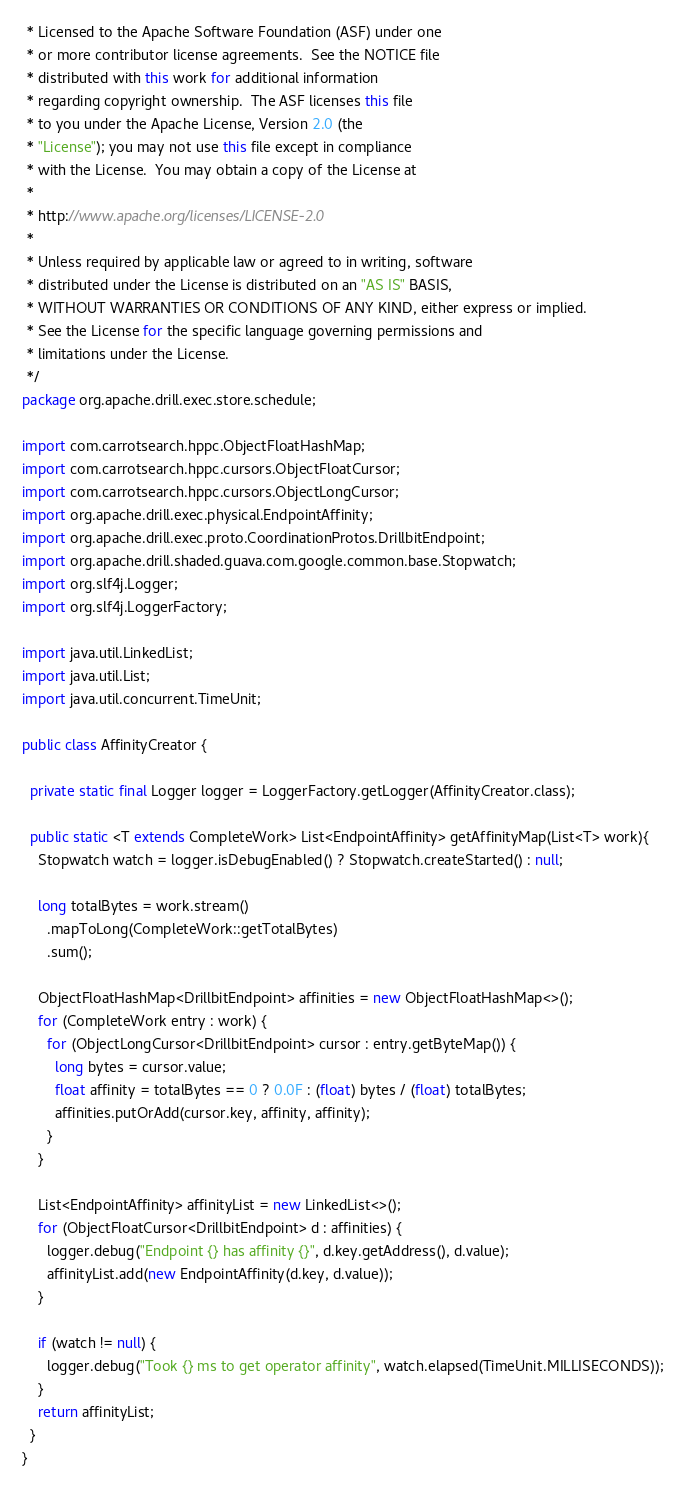Convert code to text. <code><loc_0><loc_0><loc_500><loc_500><_Java_> * Licensed to the Apache Software Foundation (ASF) under one
 * or more contributor license agreements.  See the NOTICE file
 * distributed with this work for additional information
 * regarding copyright ownership.  The ASF licenses this file
 * to you under the Apache License, Version 2.0 (the
 * "License"); you may not use this file except in compliance
 * with the License.  You may obtain a copy of the License at
 *
 * http://www.apache.org/licenses/LICENSE-2.0
 *
 * Unless required by applicable law or agreed to in writing, software
 * distributed under the License is distributed on an "AS IS" BASIS,
 * WITHOUT WARRANTIES OR CONDITIONS OF ANY KIND, either express or implied.
 * See the License for the specific language governing permissions and
 * limitations under the License.
 */
package org.apache.drill.exec.store.schedule;

import com.carrotsearch.hppc.ObjectFloatHashMap;
import com.carrotsearch.hppc.cursors.ObjectFloatCursor;
import com.carrotsearch.hppc.cursors.ObjectLongCursor;
import org.apache.drill.exec.physical.EndpointAffinity;
import org.apache.drill.exec.proto.CoordinationProtos.DrillbitEndpoint;
import org.apache.drill.shaded.guava.com.google.common.base.Stopwatch;
import org.slf4j.Logger;
import org.slf4j.LoggerFactory;

import java.util.LinkedList;
import java.util.List;
import java.util.concurrent.TimeUnit;

public class AffinityCreator {

  private static final Logger logger = LoggerFactory.getLogger(AffinityCreator.class);

  public static <T extends CompleteWork> List<EndpointAffinity> getAffinityMap(List<T> work){
    Stopwatch watch = logger.isDebugEnabled() ? Stopwatch.createStarted() : null;

    long totalBytes = work.stream()
      .mapToLong(CompleteWork::getTotalBytes)
      .sum();

    ObjectFloatHashMap<DrillbitEndpoint> affinities = new ObjectFloatHashMap<>();
    for (CompleteWork entry : work) {
      for (ObjectLongCursor<DrillbitEndpoint> cursor : entry.getByteMap()) {
        long bytes = cursor.value;
        float affinity = totalBytes == 0 ? 0.0F : (float) bytes / (float) totalBytes;
        affinities.putOrAdd(cursor.key, affinity, affinity);
      }
    }

    List<EndpointAffinity> affinityList = new LinkedList<>();
    for (ObjectFloatCursor<DrillbitEndpoint> d : affinities) {
      logger.debug("Endpoint {} has affinity {}", d.key.getAddress(), d.value);
      affinityList.add(new EndpointAffinity(d.key, d.value));
    }

    if (watch != null) {
      logger.debug("Took {} ms to get operator affinity", watch.elapsed(TimeUnit.MILLISECONDS));
    }
    return affinityList;
  }
}
</code> 